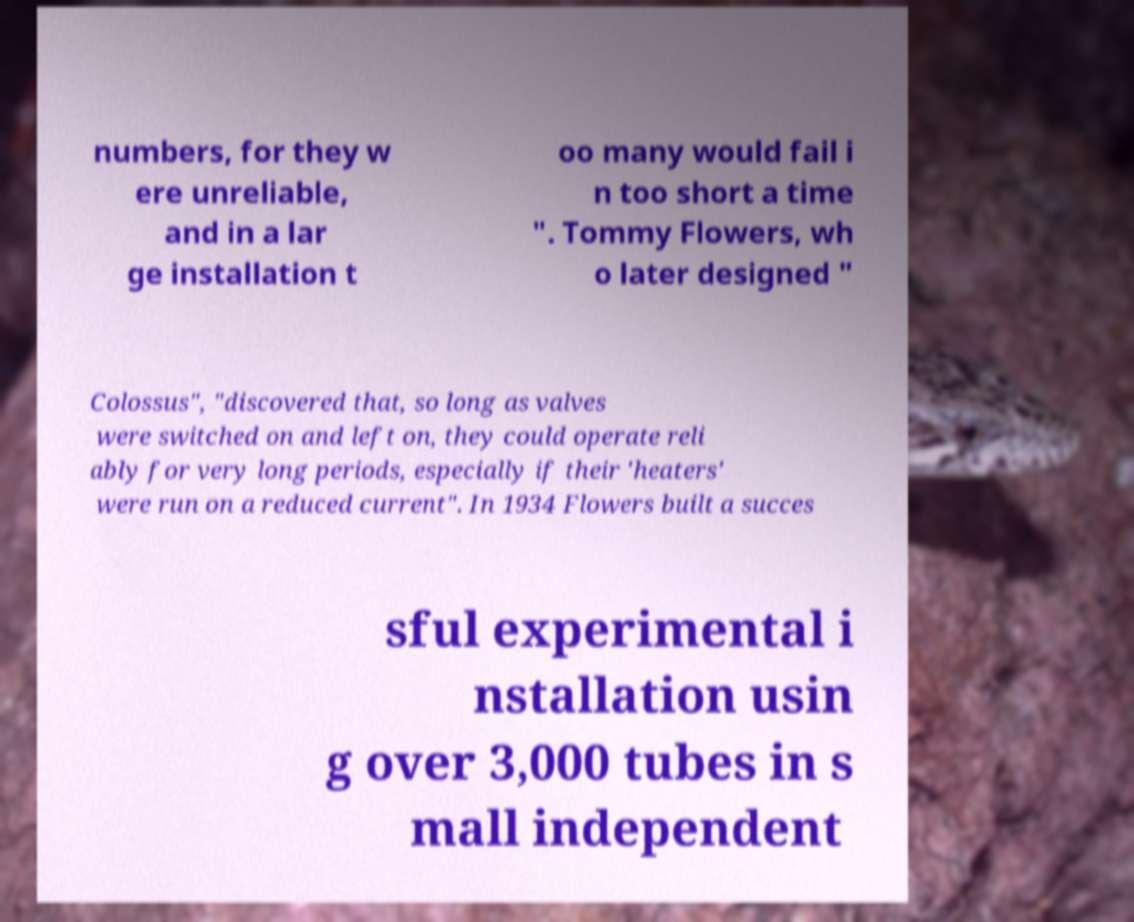Please identify and transcribe the text found in this image. numbers, for they w ere unreliable, and in a lar ge installation t oo many would fail i n too short a time ". Tommy Flowers, wh o later designed " Colossus", "discovered that, so long as valves were switched on and left on, they could operate reli ably for very long periods, especially if their 'heaters' were run on a reduced current". In 1934 Flowers built a succes sful experimental i nstallation usin g over 3,000 tubes in s mall independent 